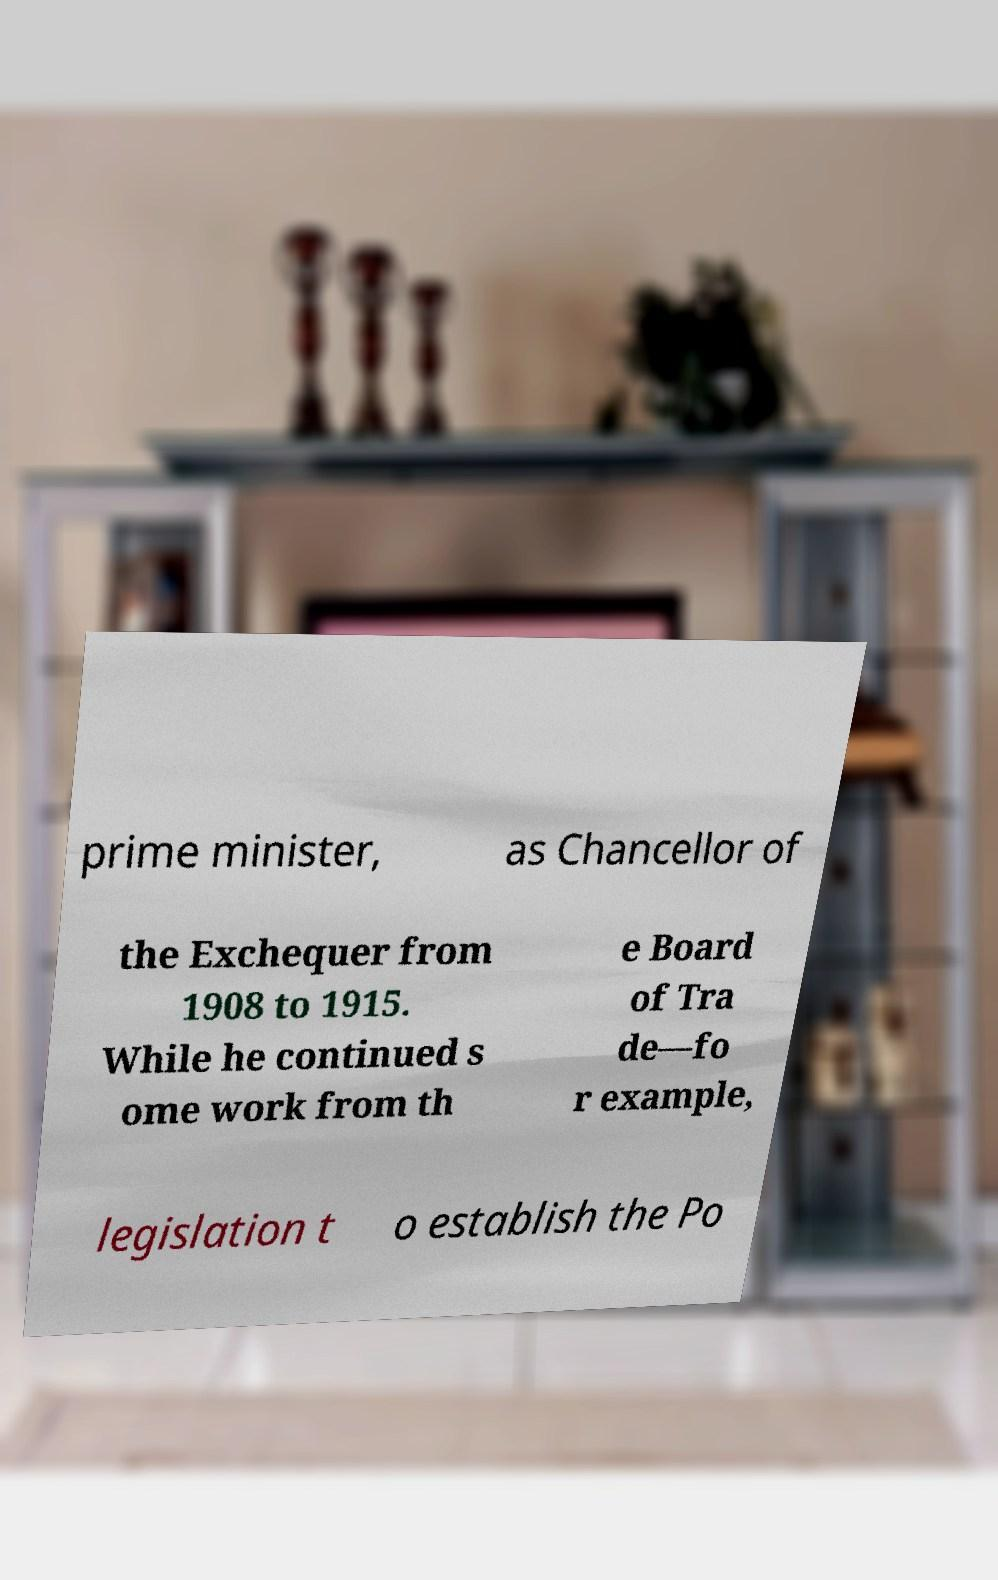There's text embedded in this image that I need extracted. Can you transcribe it verbatim? prime minister, as Chancellor of the Exchequer from 1908 to 1915. While he continued s ome work from th e Board of Tra de—fo r example, legislation t o establish the Po 